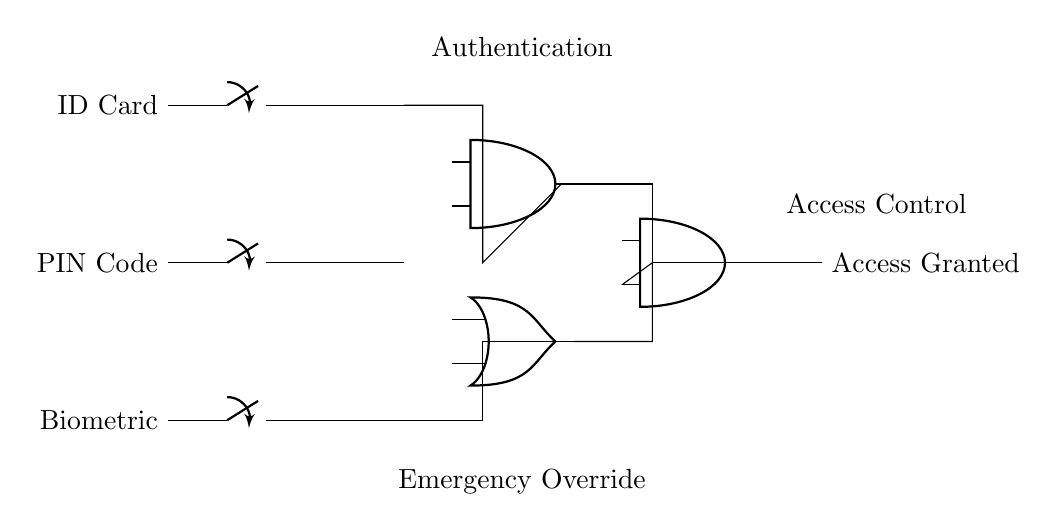What are the inputs for the access control system? The inputs are ID Card, PIN Code, and Biometric. These components allow for user identification and authentication before granting access.
Answer: ID Card, PIN Code, Biometric What type of gate is used for authentication? An AND gate is used for authentication. It requires all authentication inputs to be correct for access to be granted.
Answer: AND gate How many total inputs does the final AND gate have? The final AND gate has two inputs: one from the authentication AND gate and another from the emergency override OR gate.
Answer: Two inputs What is the purpose of the OR gate in this circuit? The OR gate serves to allow an emergency override in case the regular authentication fails or is unavailable, providing an alternate access method.
Answer: Emergency override What will happen if one of the authentication inputs is incorrect? If one of the inputs is incorrect, the authentication AND gate will not produce a high signal, resulting in access not being granted.
Answer: Access denied 